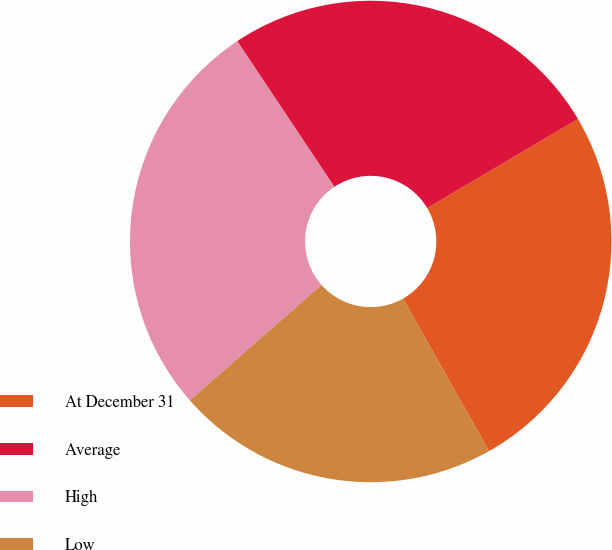Convert chart. <chart><loc_0><loc_0><loc_500><loc_500><pie_chart><fcel>At December 31<fcel>Average<fcel>High<fcel>Low<nl><fcel>25.32%<fcel>25.86%<fcel>27.12%<fcel>21.7%<nl></chart> 